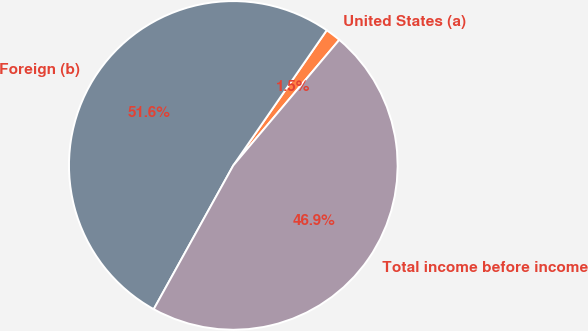Convert chart. <chart><loc_0><loc_0><loc_500><loc_500><pie_chart><fcel>United States (a)<fcel>Foreign (b)<fcel>Total income before income<nl><fcel>1.53%<fcel>51.58%<fcel>46.89%<nl></chart> 